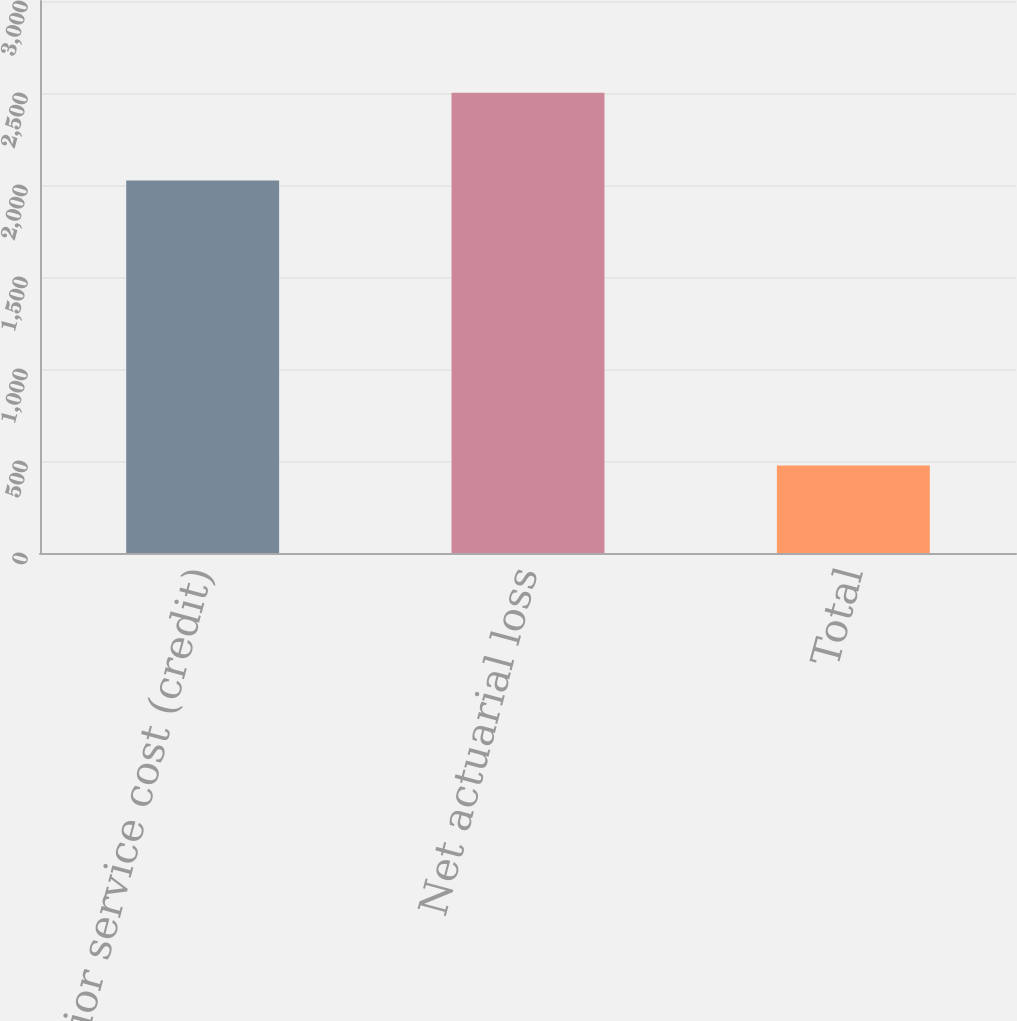Convert chart. <chart><loc_0><loc_0><loc_500><loc_500><bar_chart><fcel>Prior service cost (credit)<fcel>Net actuarial loss<fcel>Total<nl><fcel>2025<fcel>2501<fcel>476<nl></chart> 